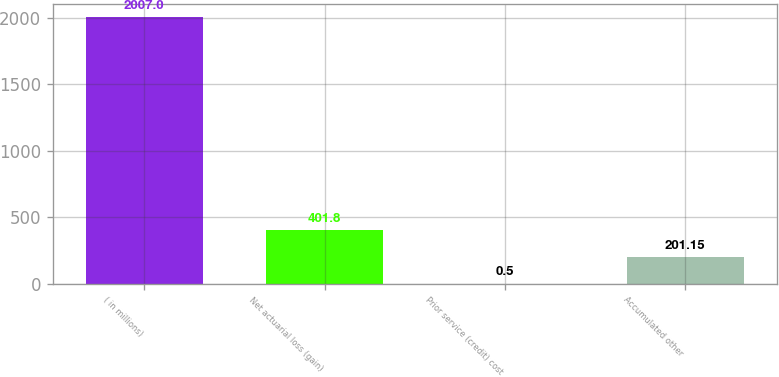Convert chart. <chart><loc_0><loc_0><loc_500><loc_500><bar_chart><fcel>( in millions)<fcel>Net actuarial loss (gain)<fcel>Prior service (credit) cost<fcel>Accumulated other<nl><fcel>2007<fcel>401.8<fcel>0.5<fcel>201.15<nl></chart> 